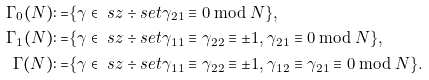<formula> <loc_0><loc_0><loc_500><loc_500>\Gamma _ { 0 } ( N ) \colon = & \{ \gamma \in \ s z \div s e t \gamma _ { 2 1 } \equiv 0 \bmod { N } \} , \\ \Gamma _ { 1 } ( N ) \colon = & \{ \gamma \in \ s z \div s e t \gamma _ { 1 1 } \equiv \gamma _ { 2 2 } \equiv \pm 1 , \gamma _ { 2 1 } \equiv 0 \bmod { N } \} , \\ \Gamma ( N ) \colon = & \{ \gamma \in \ s z \div s e t \gamma _ { 1 1 } \equiv \gamma _ { 2 2 } \equiv \pm 1 , \gamma _ { 1 2 } \equiv \gamma _ { 2 1 } \equiv 0 \bmod { N } \} .</formula> 